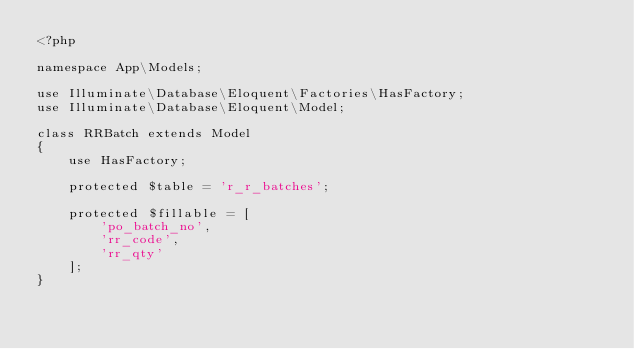<code> <loc_0><loc_0><loc_500><loc_500><_PHP_><?php

namespace App\Models;

use Illuminate\Database\Eloquent\Factories\HasFactory;
use Illuminate\Database\Eloquent\Model;

class RRBatch extends Model
{
    use HasFactory;

    protected $table = 'r_r_batches';

    protected $fillable = [
        'po_batch_no',
        'rr_code',
        'rr_qty'
    ];
}
</code> 